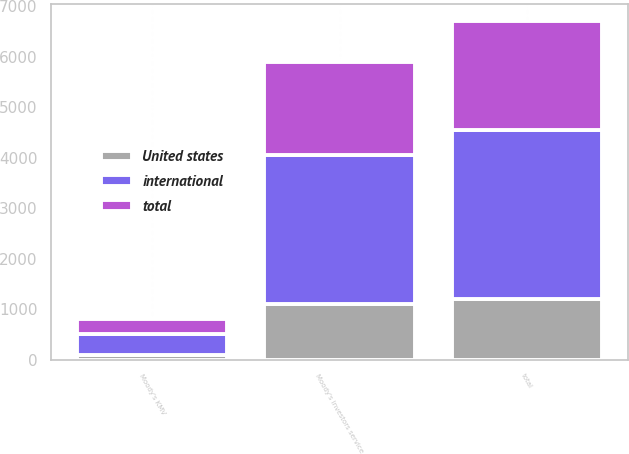Convert chart. <chart><loc_0><loc_0><loc_500><loc_500><stacked_bar_chart><ecel><fcel>Moody's investors service<fcel>Moody's KMV<fcel>total<nl><fcel>total<fcel>1843<fcel>304<fcel>2147<nl><fcel>United states<fcel>1106<fcel>97<fcel>1203<nl><fcel>international<fcel>2949<fcel>401<fcel>3350<nl></chart> 